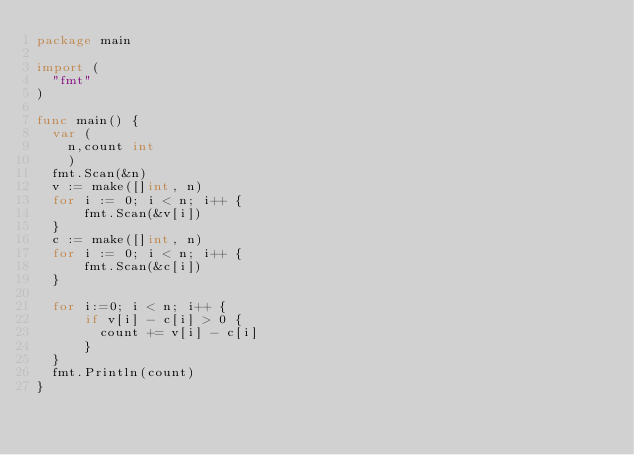<code> <loc_0><loc_0><loc_500><loc_500><_Go_>package main

import (
  "fmt"
)

func main() {
  var (
    n,count int
    )
  fmt.Scan(&n)
  v := make([]int, n)
  for i := 0; i < n; i++ {
      fmt.Scan(&v[i])
  }
  c := make([]int, n)
  for i := 0; i < n; i++ {
      fmt.Scan(&c[i])
  }

  for i:=0; i < n; i++ {
      if v[i] - c[i] > 0 {
        count += v[i] - c[i]
      }
  }
  fmt.Println(count)
}
</code> 